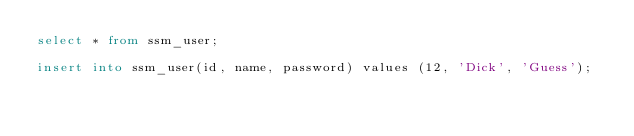<code> <loc_0><loc_0><loc_500><loc_500><_SQL_>select * from ssm_user;

insert into ssm_user(id, name, password) values (12, 'Dick', 'Guess');</code> 